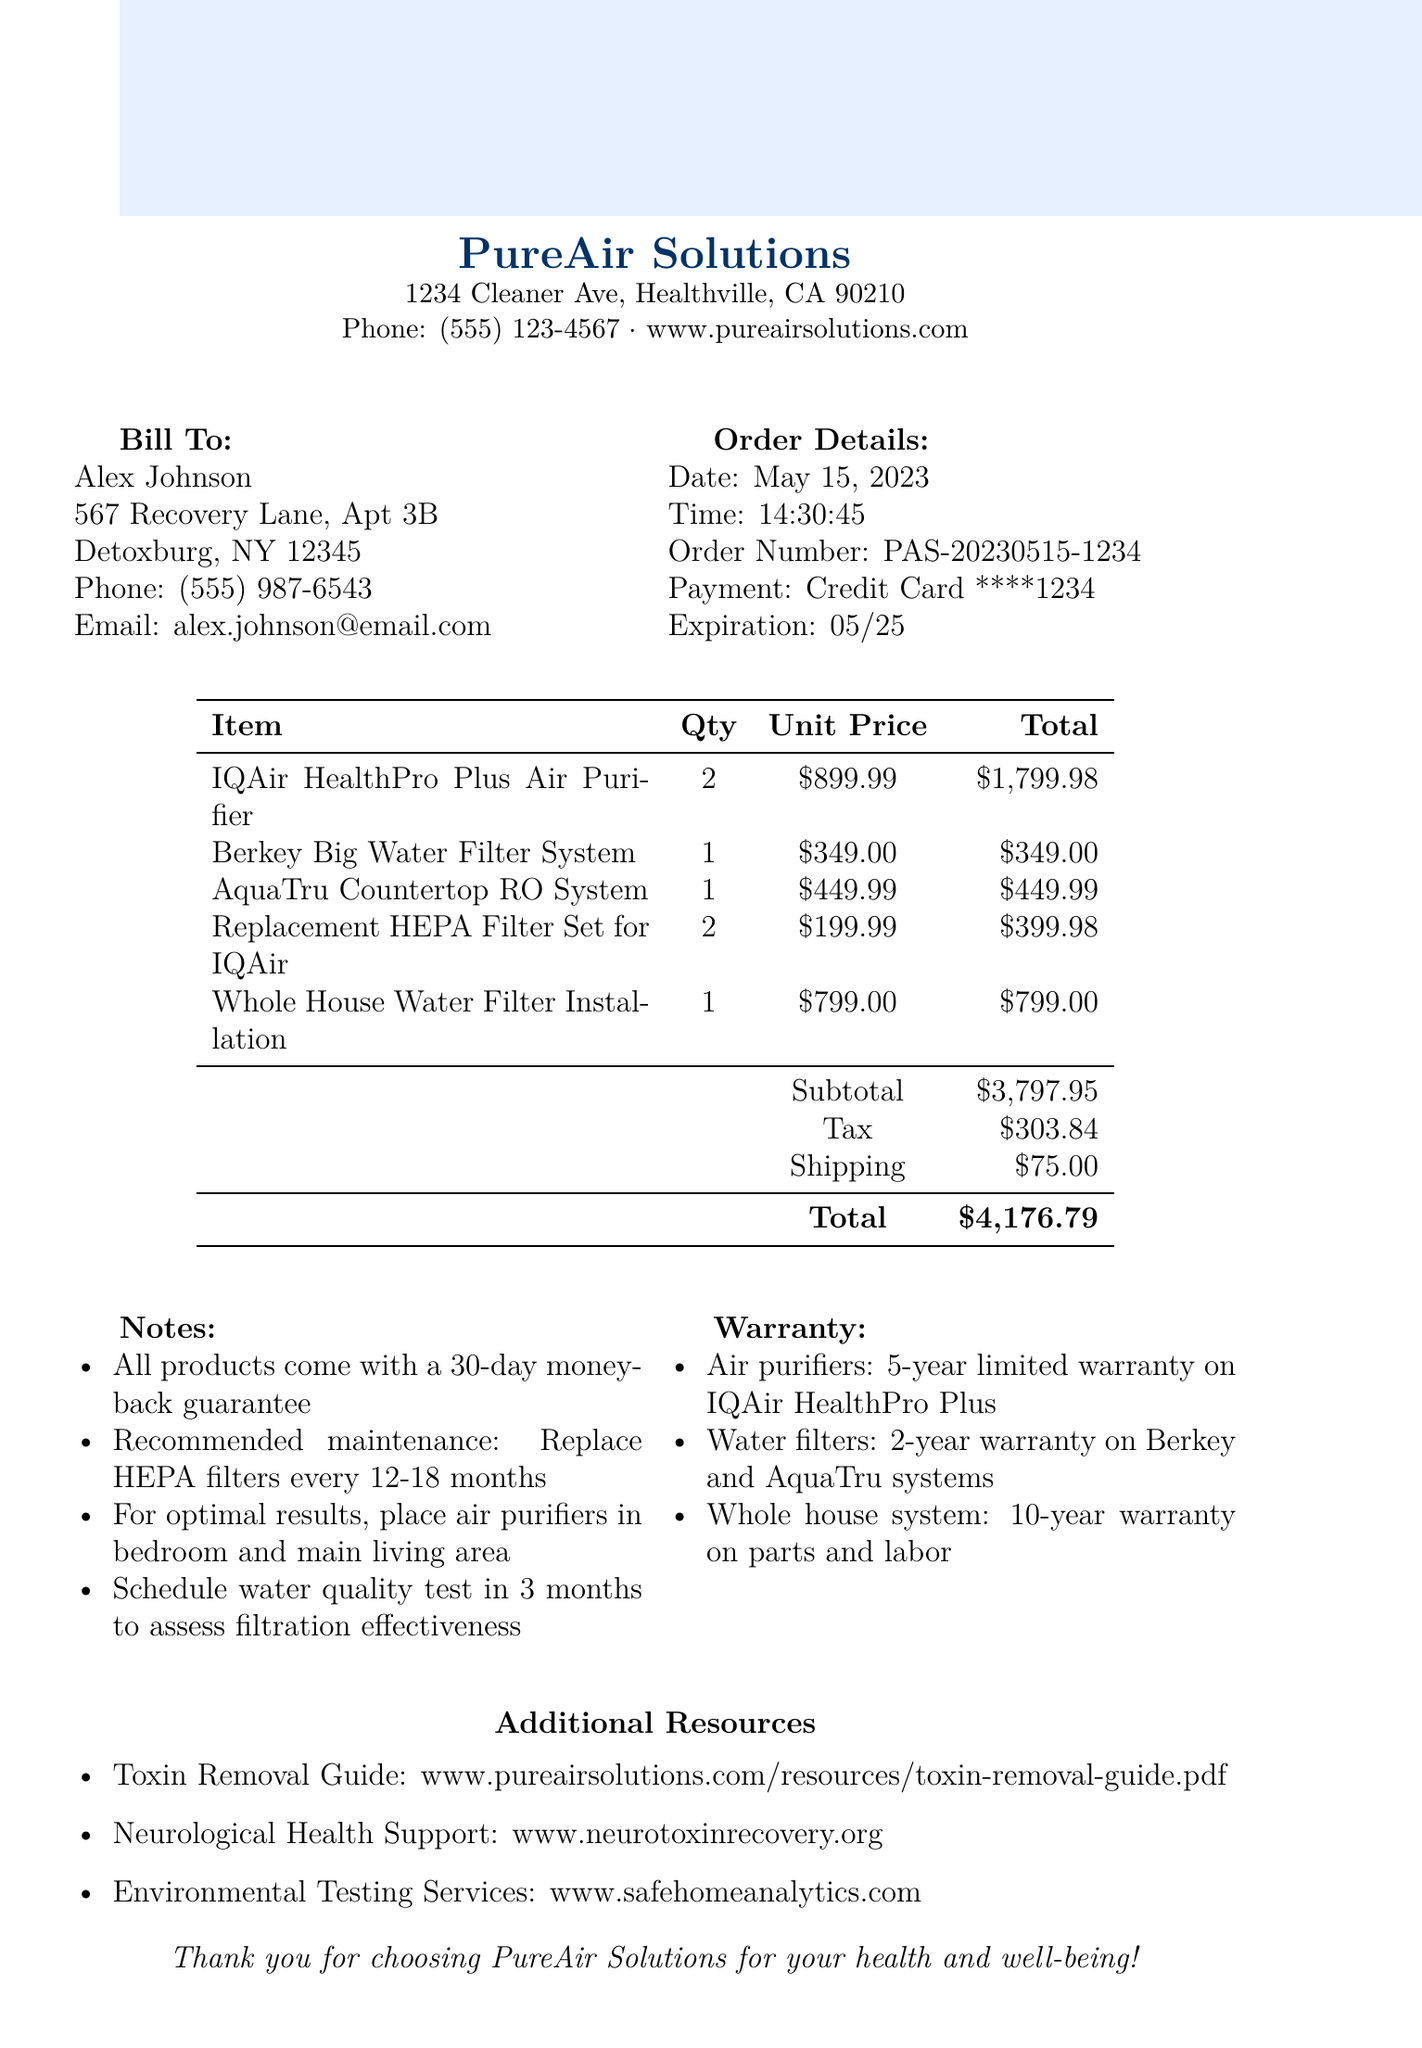what is the total amount of the transaction? The total amount is stated at the end of the transaction details, which sums up the subtotal, tax, and shipping.
Answer: $4,176.79 what is the address of PureAir Solutions? The address is provided below the merchant's name in the document.
Answer: 1234 Cleaner Ave, Healthville, CA 90210 who is the customer of this transaction? The customer name appears at the beginning under the Bill To section.
Answer: Alex Johnson how many IQAir HealthPro Plus Air Purifiers were purchased? The quantity is listed next to the item in the items table.
Answer: 2 what is the warranty period for the IQAir HealthPro Plus Air Purifier? The warranty details are listed in the warranty section.
Answer: 5-year limited warranty when was the transaction completed? The date of the transaction is provided in the Order Details section.
Answer: May 15, 2023 how much is the tax charged on the transaction? The tax amount is specified in the transaction details.
Answer: $303.84 what is included in the notes section? The notes section includes specific recommendations and guarantees related to the products.
Answer: All products come with a 30-day money-back guarantee what is the website for neurological health support? The website is listed in the Additional Resources at the end of the document.
Answer: www.neurotoxinrecovery.org 